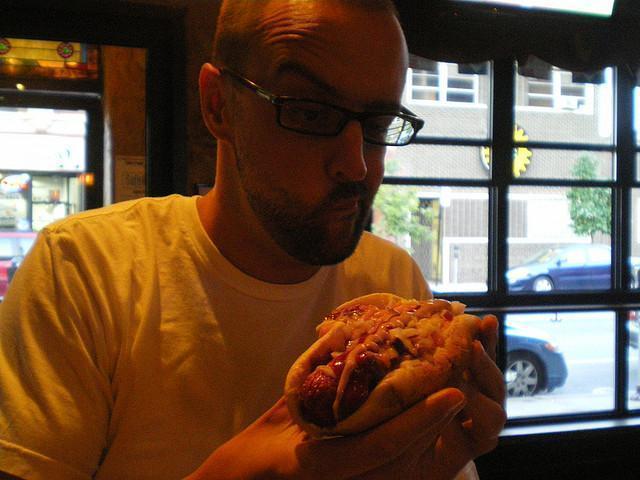Why does he have the huge sandwich?
Choose the right answer from the provided options to respond to the question.
Options: Is sharing, overloaded it, is hungry, not his. Is hungry. 